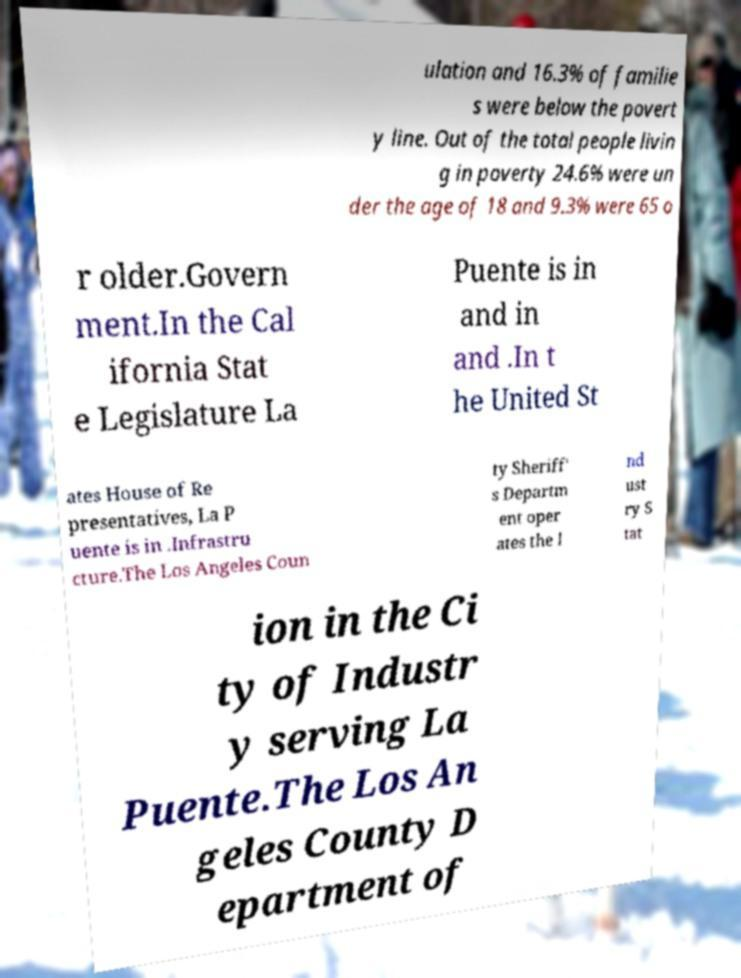Could you extract and type out the text from this image? ulation and 16.3% of familie s were below the povert y line. Out of the total people livin g in poverty 24.6% were un der the age of 18 and 9.3% were 65 o r older.Govern ment.In the Cal ifornia Stat e Legislature La Puente is in and in and .In t he United St ates House of Re presentatives, La P uente is in .Infrastru cture.The Los Angeles Coun ty Sheriff' s Departm ent oper ates the I nd ust ry S tat ion in the Ci ty of Industr y serving La Puente.The Los An geles County D epartment of 